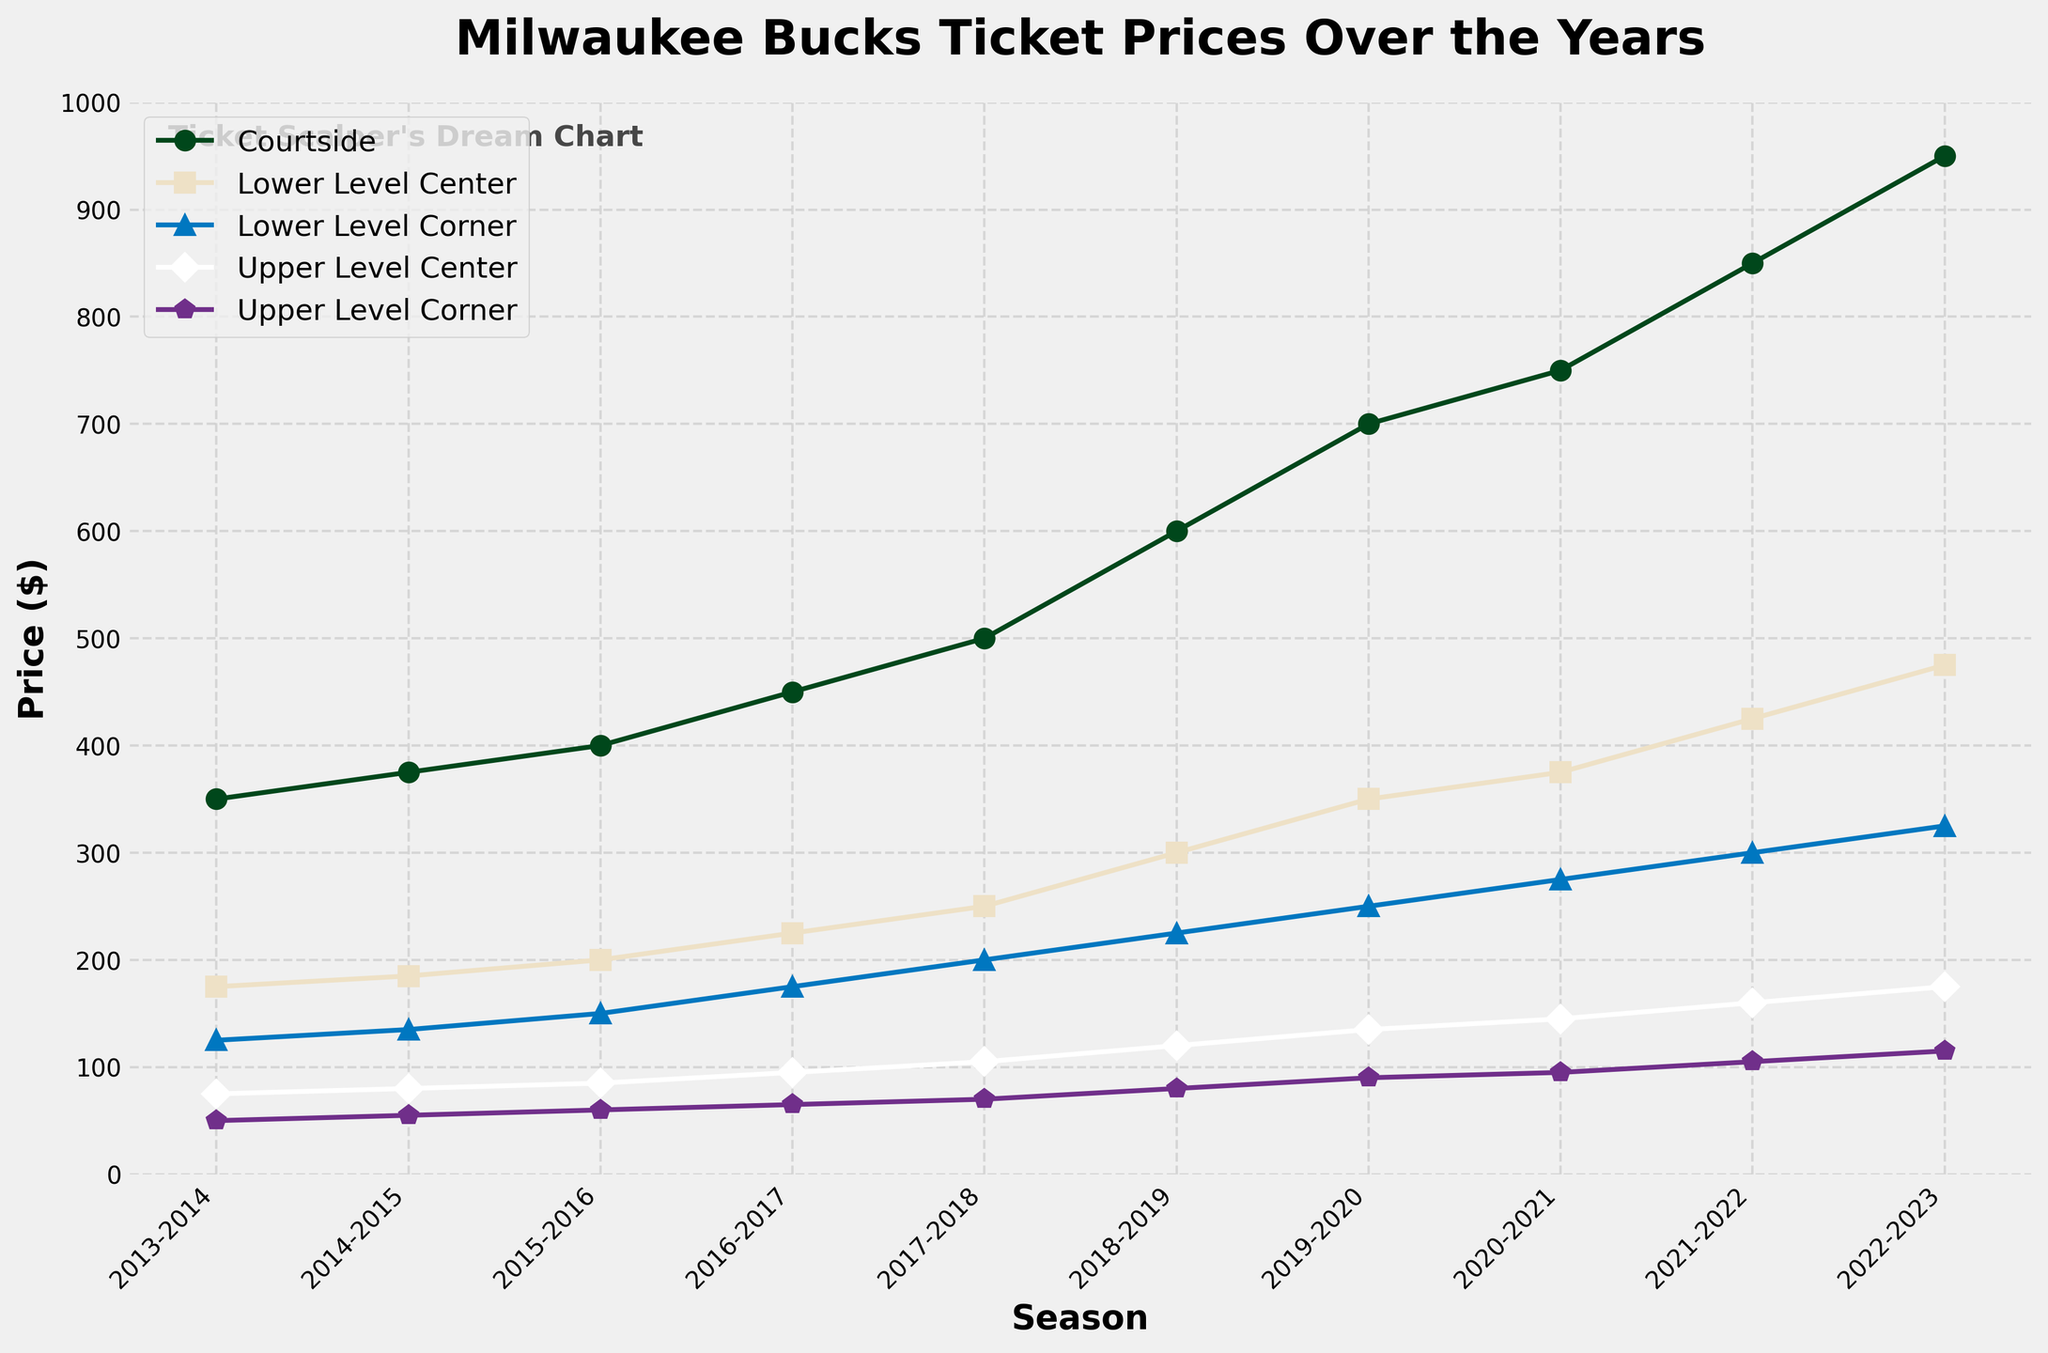Which seat section had the highest ticket price in the 2022-2023 season? The highest point on the chart for the 2022-2023 season is for the Courtside seat section.
Answer: Courtside What is the difference in price between Courtside and Lower Level Center tickets in the 2017-2018 season? Referring to the chart for the 2017-2018 season, Courtside tickets are priced at $500, while Lower Level Center tickets are priced at $250. The difference is 500 - 250 = 250.
Answer: 250 Over the ten seasons, which seat section shows the most significant increase in ticket price? By examining the slopes of the lines from 2013-2014 to 2022-2023, the Courtside section shows the steepest incline, indicating the most significant increase in price.
Answer: Courtside During which season did the ticket price for Upper Level Center first exceed $100? The Upper Level Center ticket price first exceeds $100 in the 2017-2018 season, where it's marked at $105.
Answer: 2017-2018 What is the average ticket price for Lower Level Corner tickets over the 10 seasons? Add the ticket prices for Lower Level Corner from each season: (125 + 135 + 150 + 175 + 200 + 225 + 250 + 275 + 300 + 325) = 2160, and then divide this total by the number of seasons (10). 2160 / 10 = 216.
Answer: 216 Compare the price trends of Lower Level Center and Upper Level Corner seats. Which has seen a more consistent increase? Both lines show an increasing trend, but Upper Level Corner shows a more constant, gentle slope without sharp increments, indicating a more consistent increase compared to Lower Level Center, which has larger price jumps.
Answer: Upper Level Corner What is the ratio of the ticket price for Upper Level Corner to Lower Level Corner in the 2019-2020 season? Upper Level Corner price is $90, and Lower Level Corner is $250 in 2019-2020. The ratio is 90 / 250 = 0.36.
Answer: 0.36 How many seasons have Courtside tickets been above $500? Courtside tickets surpassed $500 starting from the 2018-2019 season and continue to stay above $500 for five seasons (2018-2019 to 2022-2023).
Answer: 5 Which season recorded the highest price increase for Lower Level Center tickets? By tracing the steps between each point on the Lower Level Center line, the highest increase is seen between 2021-2022 and 2022-2023, where the price jumps from $425 to $475, an increase of $50.
Answer: 2021-2022 to 2022-2023 